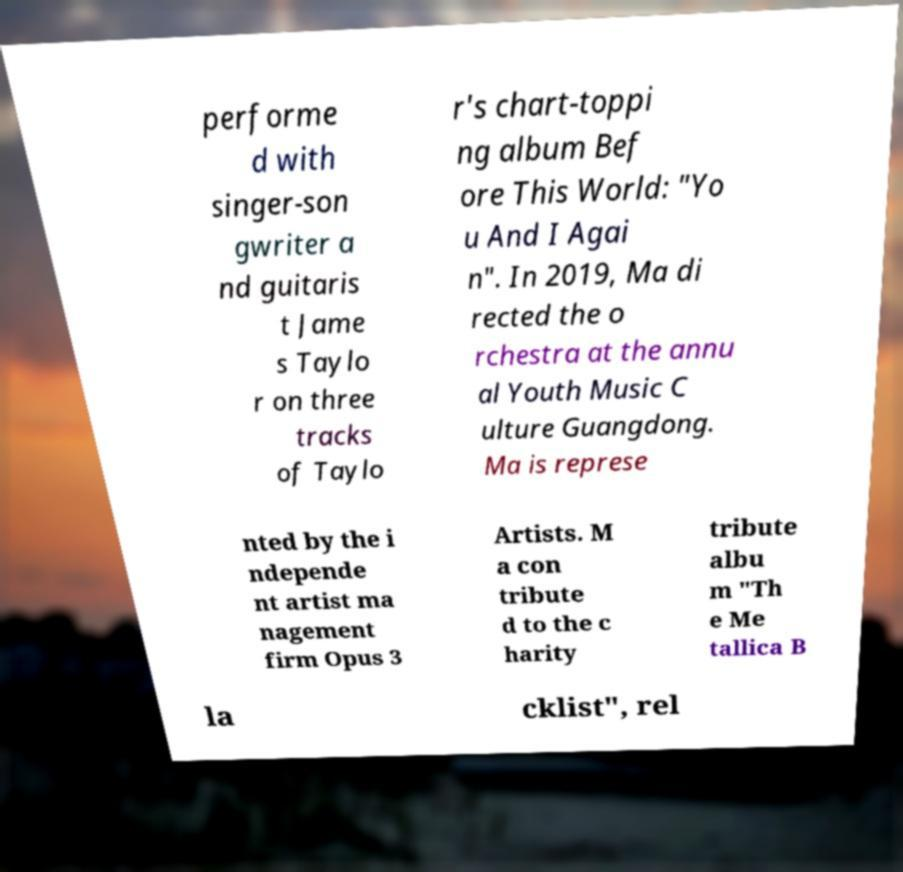For documentation purposes, I need the text within this image transcribed. Could you provide that? performe d with singer-son gwriter a nd guitaris t Jame s Taylo r on three tracks of Taylo r's chart-toppi ng album Bef ore This World: "Yo u And I Agai n". In 2019, Ma di rected the o rchestra at the annu al Youth Music C ulture Guangdong. Ma is represe nted by the i ndepende nt artist ma nagement firm Opus 3 Artists. M a con tribute d to the c harity tribute albu m "Th e Me tallica B la cklist", rel 